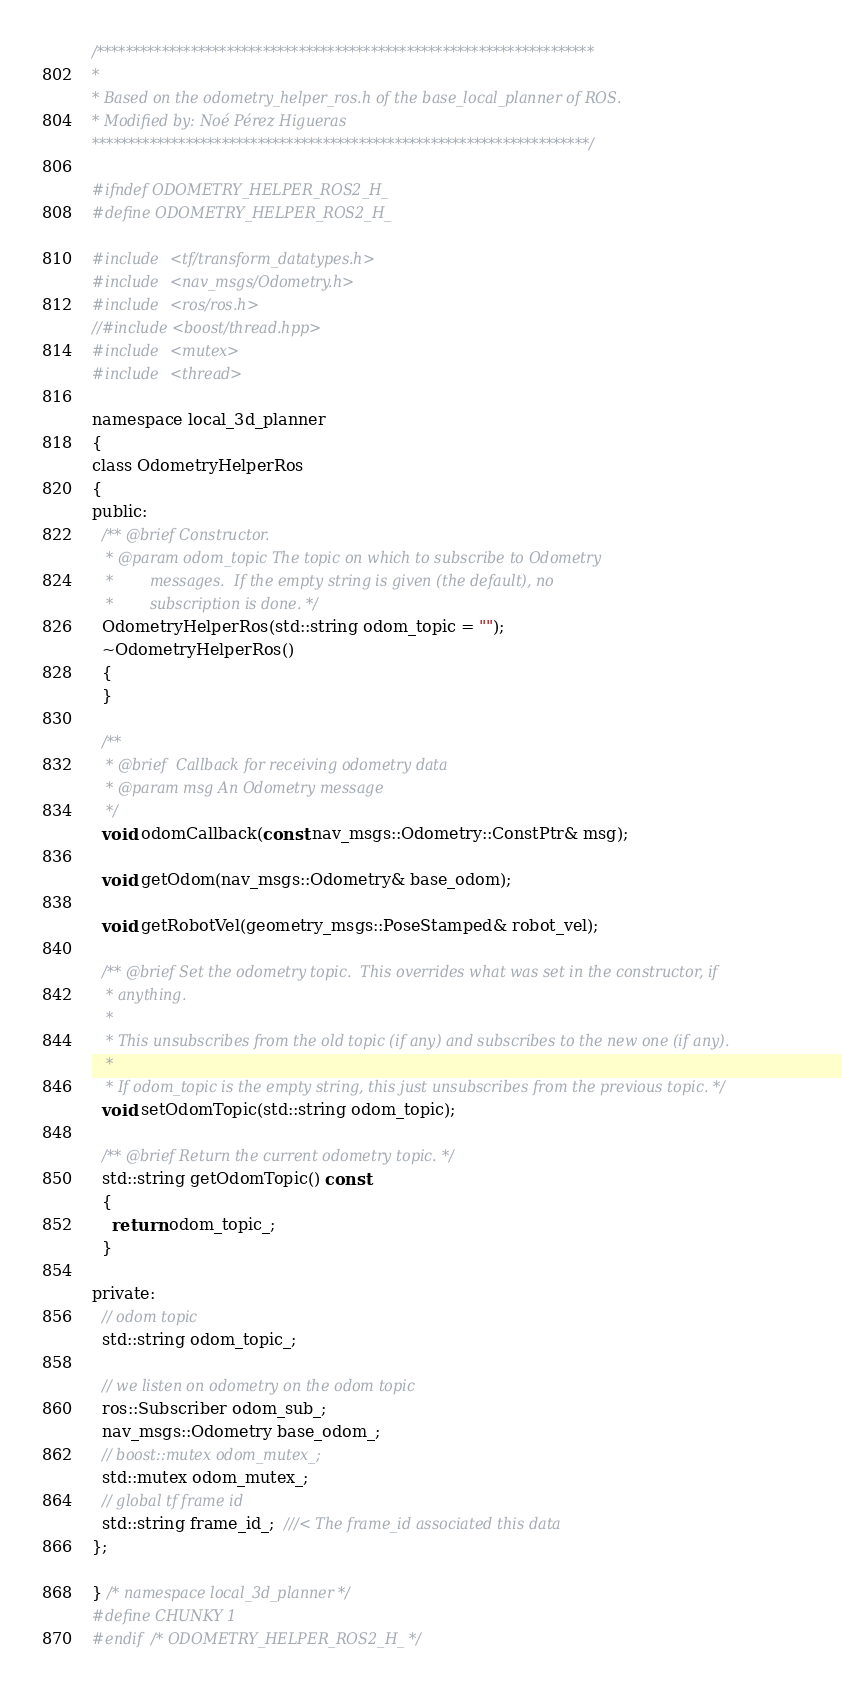<code> <loc_0><loc_0><loc_500><loc_500><_C_>/*********************************************************************
*
* Based on the odometry_helper_ros.h of the base_local_planner of ROS.
* Modified by: Noé Pérez Higueras
*********************************************************************/

#ifndef ODOMETRY_HELPER_ROS2_H_
#define ODOMETRY_HELPER_ROS2_H_

#include <tf/transform_datatypes.h>
#include <nav_msgs/Odometry.h>
#include <ros/ros.h>
//#include <boost/thread.hpp>
#include <mutex>
#include <thread>

namespace local_3d_planner
{
class OdometryHelperRos
{
public:
  /** @brief Constructor.
   * @param odom_topic The topic on which to subscribe to Odometry
   *        messages.  If the empty string is given (the default), no
   *        subscription is done. */
  OdometryHelperRos(std::string odom_topic = "");
  ~OdometryHelperRos()
  {
  }

  /**
   * @brief  Callback for receiving odometry data
   * @param msg An Odometry message
   */
  void odomCallback(const nav_msgs::Odometry::ConstPtr& msg);

  void getOdom(nav_msgs::Odometry& base_odom);

  void getRobotVel(geometry_msgs::PoseStamped& robot_vel);

  /** @brief Set the odometry topic.  This overrides what was set in the constructor, if
   * anything.
   *
   * This unsubscribes from the old topic (if any) and subscribes to the new one (if any).
   *
   * If odom_topic is the empty string, this just unsubscribes from the previous topic. */
  void setOdomTopic(std::string odom_topic);

  /** @brief Return the current odometry topic. */
  std::string getOdomTopic() const
  {
    return odom_topic_;
  }

private:
  // odom topic
  std::string odom_topic_;

  // we listen on odometry on the odom topic
  ros::Subscriber odom_sub_;
  nav_msgs::Odometry base_odom_;
  // boost::mutex odom_mutex_;
  std::mutex odom_mutex_;
  // global tf frame id
  std::string frame_id_;  ///< The frame_id associated this data
};

} /* namespace local_3d_planner */
#define CHUNKY 1
#endif /* ODOMETRY_HELPER_ROS2_H_ */
</code> 